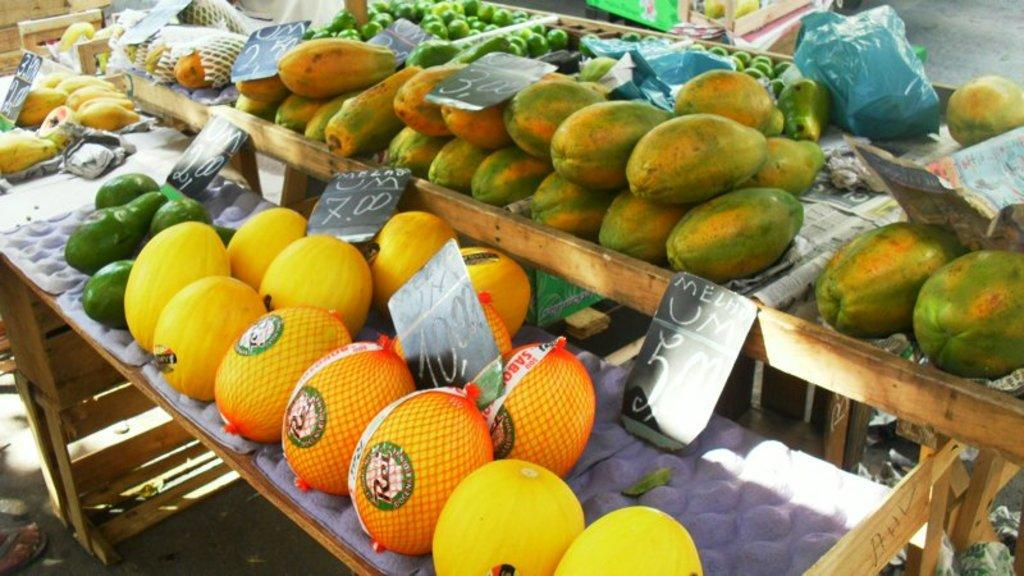What type of furniture is present in the image? There are tables in the image. What is placed on the tables? Fruits are placed on the tables. What other objects can be seen in the image? There are boards and covers in the image. How many horses are visible in the image? There are no horses present in the image. What type of cheese is placed on the tables in the image? There is no cheese present in the image; only fruits are placed on the tables. 